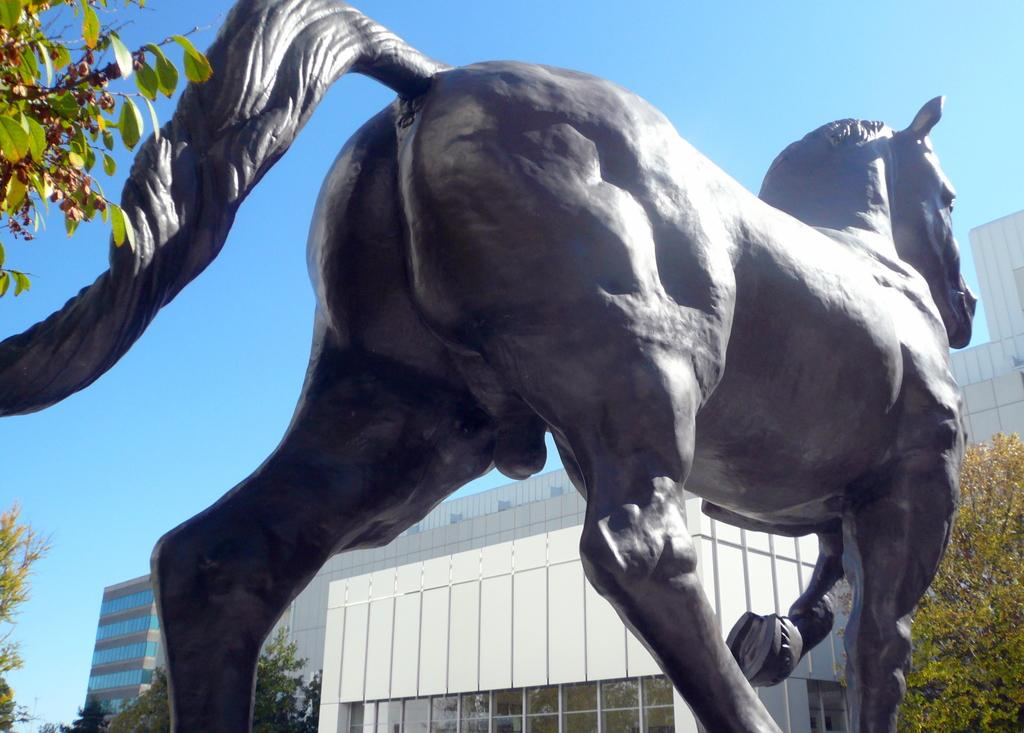What is the main subject of the image? There is a statue of a horse in the image. What can be seen in the left corner of the image? There is a tree in the left corner of the image. What is visible in the background of the image? There are buildings and trees in the background of the image. What type of egg is being cooked in the oven in the image? There is no egg or oven present in the image; it features a statue of a horse and other elements in the background. 